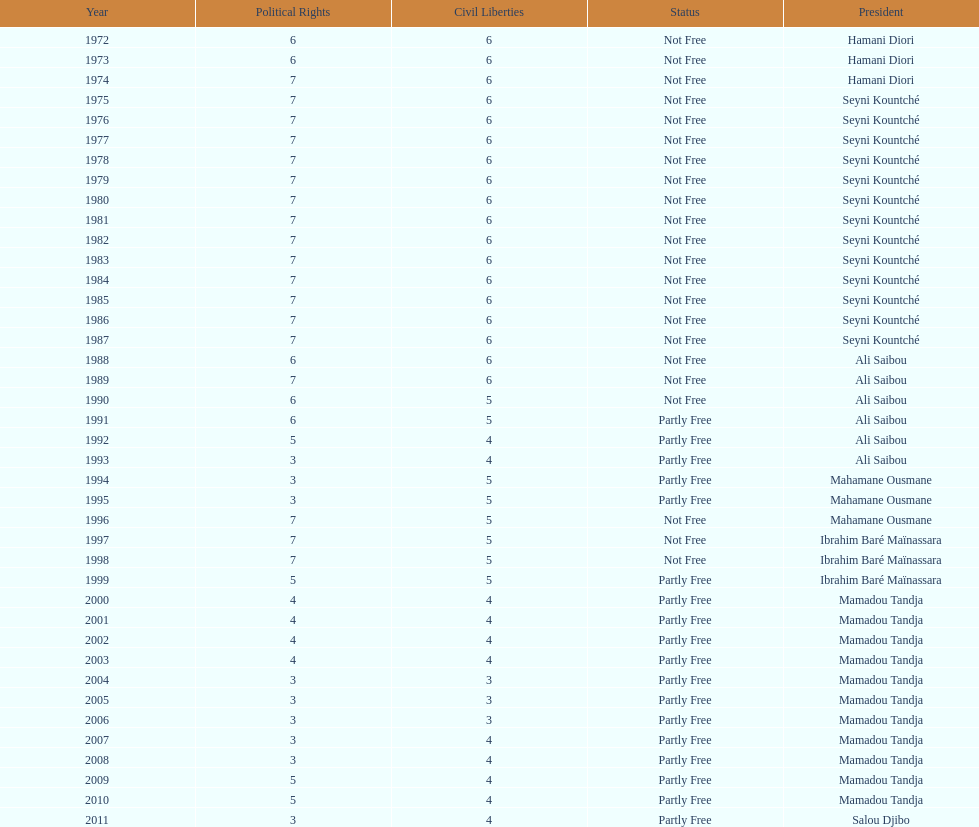How many years was it before the first partly free status? 18. 